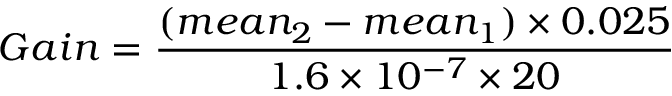Convert formula to latex. <formula><loc_0><loc_0><loc_500><loc_500>G a i n = \frac { ( m e a n _ { 2 } - m e a n _ { 1 } ) \times 0 . 0 2 5 } { 1 . 6 \times 1 0 ^ { - 7 } \times 2 0 }</formula> 